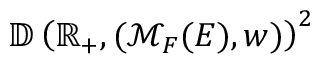<formula> <loc_0><loc_0><loc_500><loc_500>\mathbb { D } \left ( \mathbb { R } _ { + } , ( \mathcal { M } _ { F } ( E ) , w ) \right ) ^ { 2 }</formula> 